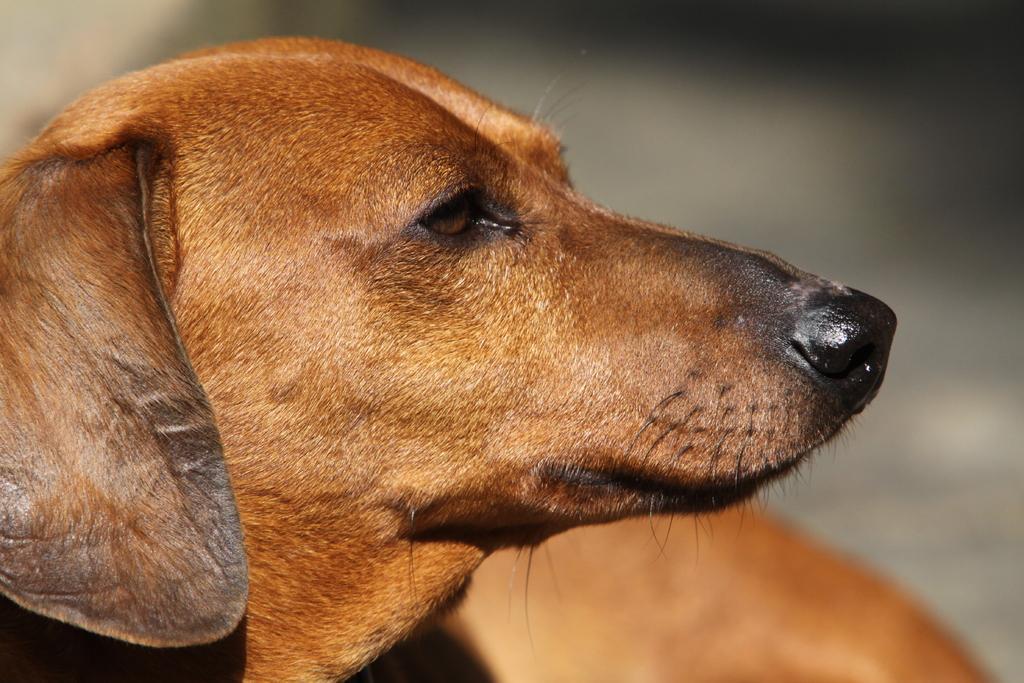Can you describe this image briefly? In this image I can see an animal and the animal is in brown color and I can see the blurred background. 